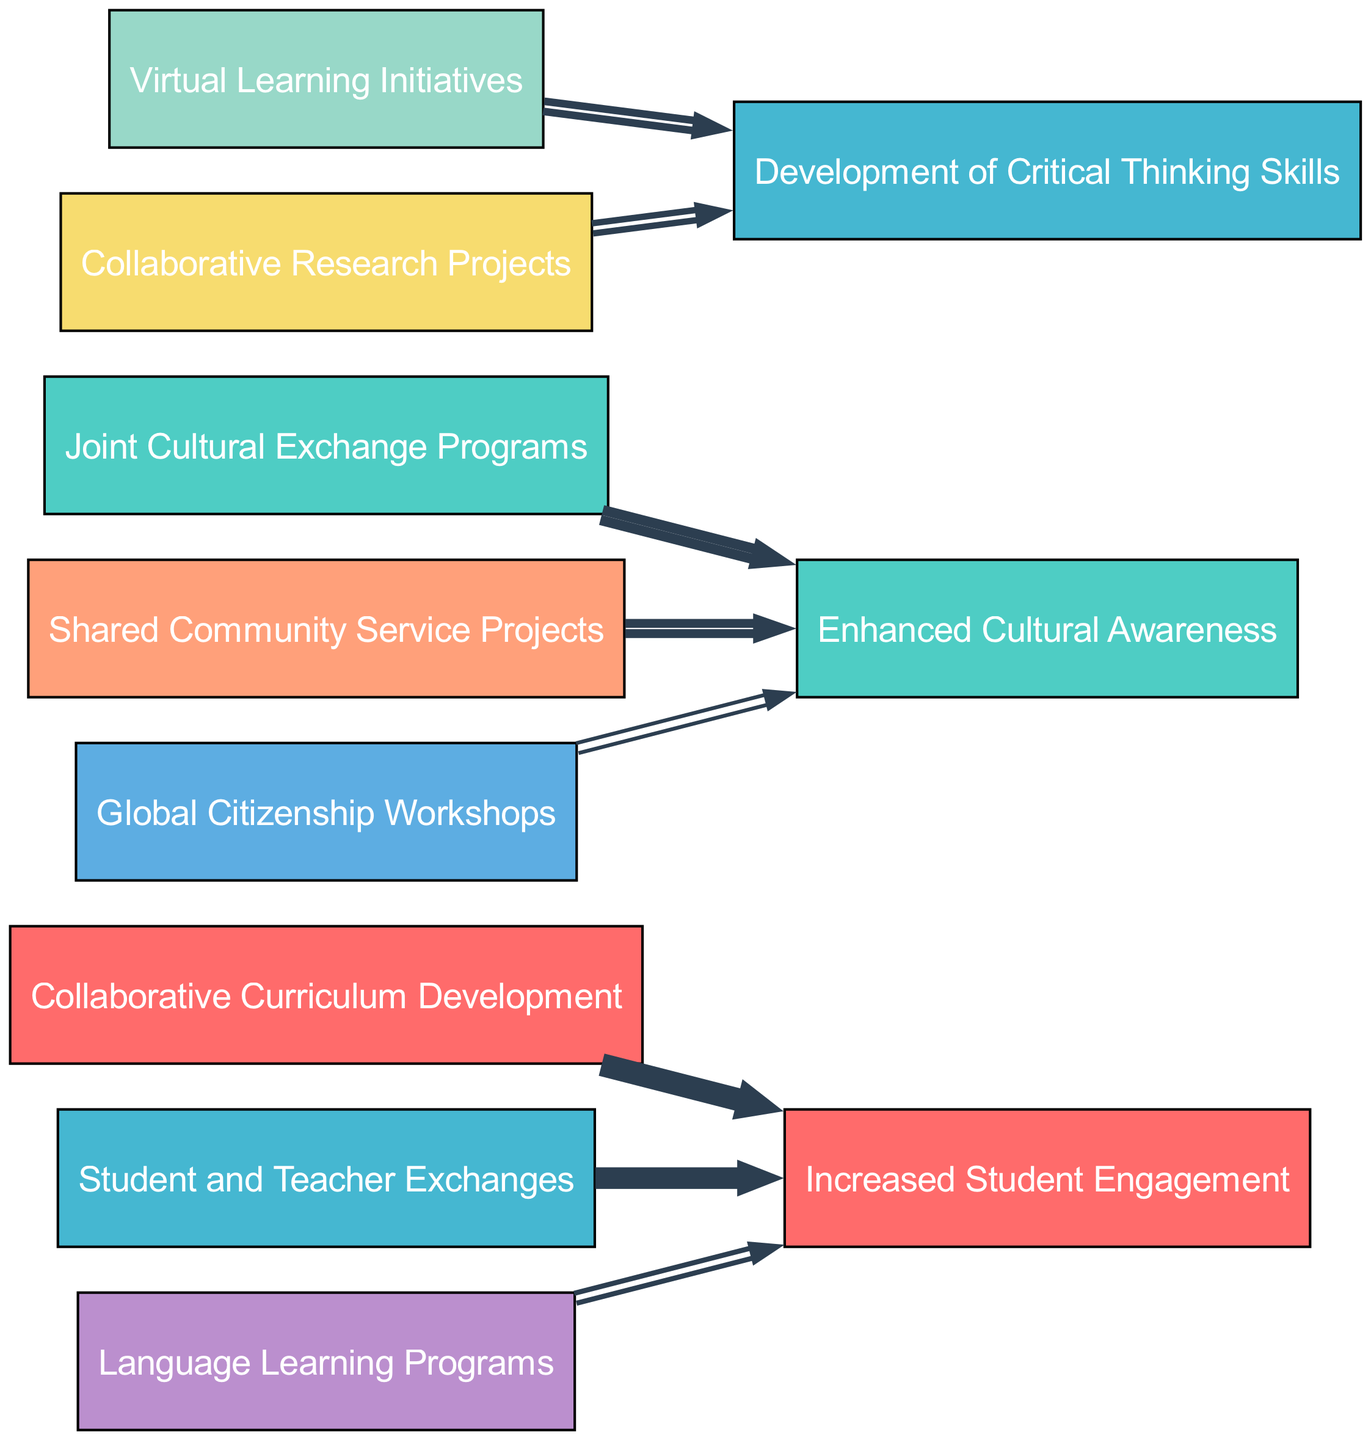What are the total number of nodes in the diagram? The diagram lists eight distinct nodes that represent various collaborative projects. By counting each unique node, the total number is determined to be eight.
Answer: 8 Which project has the highest connection to increased student engagement? By examining the links, the collaborative curriculum development, with a value of 10, has the highest connection to increased student engagement as it flows directly to that outcome.
Answer: Collaborative Curriculum Development How many total links are present in the diagram? The diagram reveals a total of eight links connecting various projects to their outcomes. By counting each connection shown in the links section, we arrive at the total of eight.
Answer: 8 What is the value associated with joint cultural exchange programs? The diagram indicates that joint cultural exchange programs link to enhanced cultural awareness with a value of 8, showing its strength in this partnership.
Answer: 8 Which two projects contribute equally to the development of critical thinking skills? The virtual learning initiatives and collaborative research projects both contribute to the development of critical thinking skills, each with a value of 6 and 5 respectively. Comparing their values, we can confirm they have a significant but not equal impact.
Answer: Virtual Learning Initiatives and Collaborative Research Projects What is the flow of the project with the least impact on increased student engagement? By reviewing the links, language learning programs have a value of 4, representing the least impact among the projects that aim for increased student engagement. This can be inferred as it connects directly to that outcome with the lowest value.
Answer: Language Learning Programs Identify a project that leads to enhanced cultural awareness. The joint cultural exchange programs directly lead to enhanced cultural awareness, as indicated by its link with a value of 8 in the diagram. Thus, it is a clear contributor toward this outcome.
Answer: Joint Cultural Exchange Programs Which outcome has the least value across all projects? After analyzing the links for values, global citizenship workshops contribute the least, with a flow value of 3, indicating it is the outcome with the minimal impact based on the collaborations.
Answer: 3 